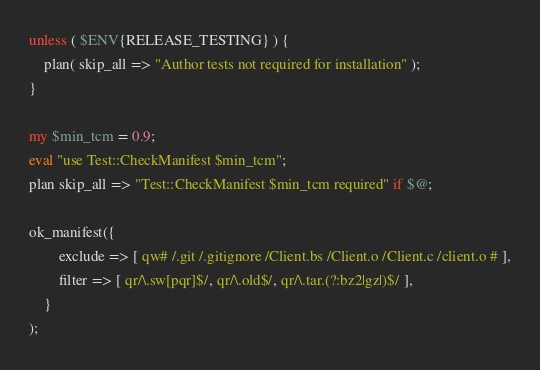<code> <loc_0><loc_0><loc_500><loc_500><_Perl_>unless ( $ENV{RELEASE_TESTING} ) {
    plan( skip_all => "Author tests not required for installation" );
}

my $min_tcm = 0.9;
eval "use Test::CheckManifest $min_tcm";
plan skip_all => "Test::CheckManifest $min_tcm required" if $@;

ok_manifest({
        exclude => [ qw# /.git /.gitignore /Client.bs /Client.o /Client.c /client.o # ],
        filter => [ qr/\.sw[pqr]$/, qr/\.old$/, qr/\.tar.(?:bz2|gz|)$/ ],
    }
);

</code> 